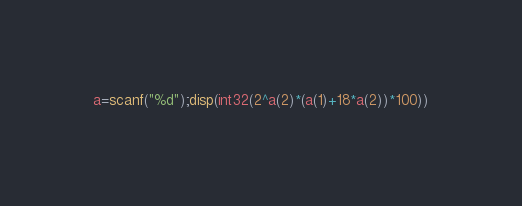<code> <loc_0><loc_0><loc_500><loc_500><_Octave_>a=scanf("%d");disp(int32(2^a(2)*(a(1)+18*a(2))*100))</code> 